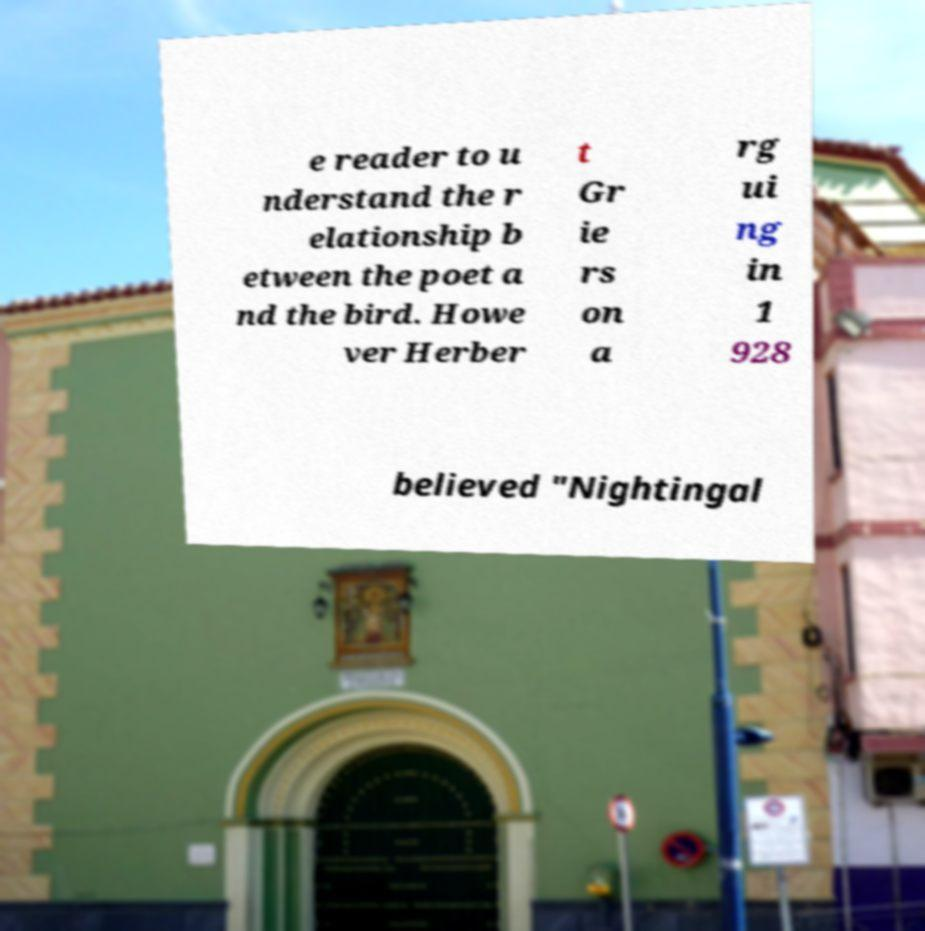Can you read and provide the text displayed in the image?This photo seems to have some interesting text. Can you extract and type it out for me? e reader to u nderstand the r elationship b etween the poet a nd the bird. Howe ver Herber t Gr ie rs on a rg ui ng in 1 928 believed "Nightingal 